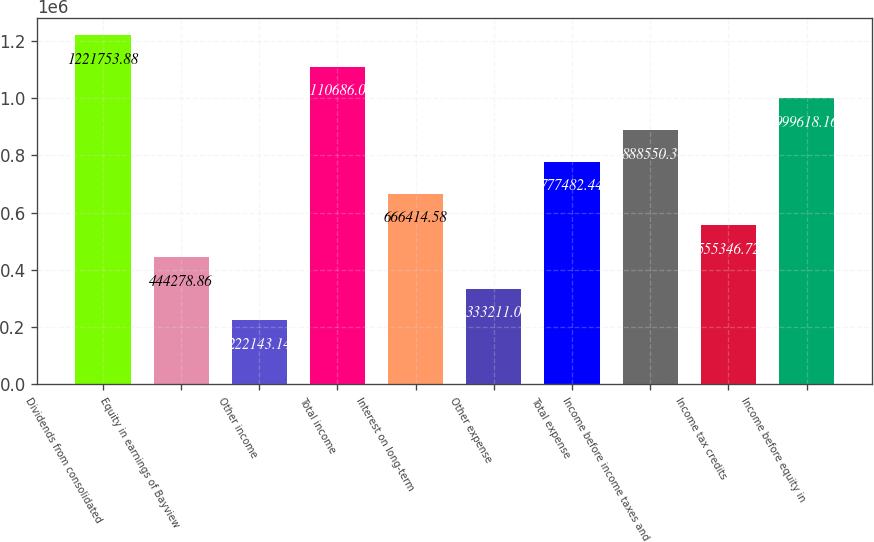Convert chart. <chart><loc_0><loc_0><loc_500><loc_500><bar_chart><fcel>Dividends from consolidated<fcel>Equity in earnings of Bayview<fcel>Other income<fcel>Total income<fcel>Interest on long-term<fcel>Other expense<fcel>Total expense<fcel>Income before income taxes and<fcel>Income tax credits<fcel>Income before equity in<nl><fcel>1.22175e+06<fcel>444279<fcel>222143<fcel>1.11069e+06<fcel>666415<fcel>333211<fcel>777482<fcel>888550<fcel>555347<fcel>999618<nl></chart> 